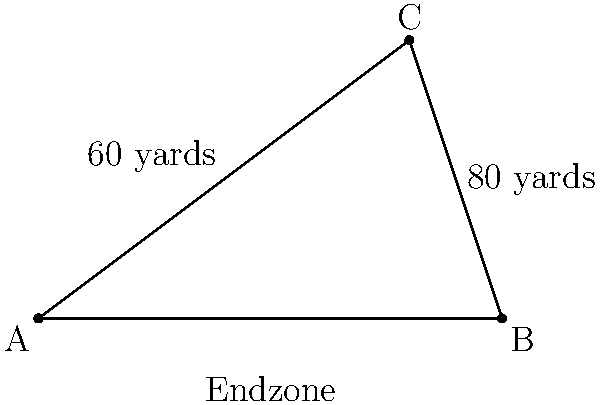In a crucial play designed for Drew Brees, a receiver runs a route from point A to C on the diagram. If the endzone line (AB) is 100 yards long, and the receiver's route covers 60 yards vertically and 80 yards horizontally, what is the angle (in degrees) between the receiver's route (AC) and the endzone line (AB)? To find the angle between the receiver's route and the endzone line, we can use the arctangent function. Here's how:

1) In the right triangle ABC, we know:
   - The vertical distance (opposite side) is 60 yards
   - The horizontal distance (adjacent side) is 80 yards

2) The tangent of the angle we're looking for is the ratio of the opposite side to the adjacent side:

   $$\tan(\theta) = \frac{\text{opposite}}{\text{adjacent}} = \frac{60}{80} = \frac{3}{4} = 0.75$$

3) To find the angle, we need to take the inverse tangent (arctangent) of this ratio:

   $$\theta = \arctan(0.75)$$

4) Using a calculator or mathematical software:

   $$\theta \approx 36.87\text{°}$$

5) Rounding to the nearest degree:

   $$\theta \approx 37\text{°}$$

Thus, the angle between the receiver's route and the endzone line is approximately 37 degrees.
Answer: 37° 